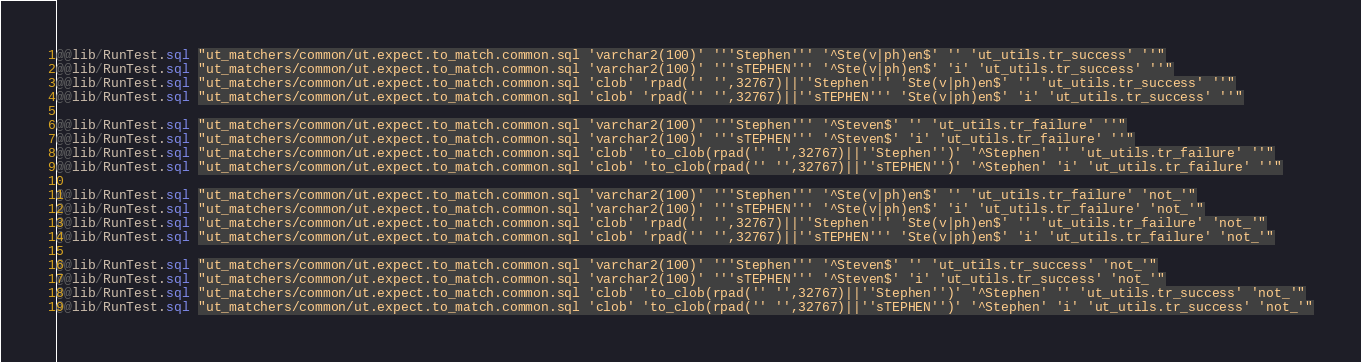Convert code to text. <code><loc_0><loc_0><loc_500><loc_500><_SQL_>@@lib/RunTest.sql "ut_matchers/common/ut.expect.to_match.common.sql 'varchar2(100)' '''Stephen''' '^Ste(v|ph)en$' '' 'ut_utils.tr_success' ''"
@@lib/RunTest.sql "ut_matchers/common/ut.expect.to_match.common.sql 'varchar2(100)' '''sTEPHEN''' '^Ste(v|ph)en$' 'i' 'ut_utils.tr_success' ''"
@@lib/RunTest.sql "ut_matchers/common/ut.expect.to_match.common.sql 'clob' 'rpad('' '',32767)||''Stephen''' 'Ste(v|ph)en$' '' 'ut_utils.tr_success' ''"
@@lib/RunTest.sql "ut_matchers/common/ut.expect.to_match.common.sql 'clob' 'rpad('' '',32767)||''sTEPHEN''' 'Ste(v|ph)en$' 'i' 'ut_utils.tr_success' ''"

@@lib/RunTest.sql "ut_matchers/common/ut.expect.to_match.common.sql 'varchar2(100)' '''Stephen''' '^Steven$' '' 'ut_utils.tr_failure' ''"
@@lib/RunTest.sql "ut_matchers/common/ut.expect.to_match.common.sql 'varchar2(100)' '''sTEPHEN''' '^Steven$' 'i' 'ut_utils.tr_failure' ''"
@@lib/RunTest.sql "ut_matchers/common/ut.expect.to_match.common.sql 'clob' 'to_clob(rpad('' '',32767)||''Stephen'')' '^Stephen' '' 'ut_utils.tr_failure' ''"
@@lib/RunTest.sql "ut_matchers/common/ut.expect.to_match.common.sql 'clob' 'to_clob(rpad('' '',32767)||''sTEPHEN'')' '^Stephen' 'i' 'ut_utils.tr_failure' ''"

@@lib/RunTest.sql "ut_matchers/common/ut.expect.to_match.common.sql 'varchar2(100)' '''Stephen''' '^Ste(v|ph)en$' '' 'ut_utils.tr_failure' 'not_'"
@@lib/RunTest.sql "ut_matchers/common/ut.expect.to_match.common.sql 'varchar2(100)' '''sTEPHEN''' '^Ste(v|ph)en$' 'i' 'ut_utils.tr_failure' 'not_'"
@@lib/RunTest.sql "ut_matchers/common/ut.expect.to_match.common.sql 'clob' 'rpad('' '',32767)||''Stephen''' 'Ste(v|ph)en$' '' 'ut_utils.tr_failure' 'not_'"
@@lib/RunTest.sql "ut_matchers/common/ut.expect.to_match.common.sql 'clob' 'rpad('' '',32767)||''sTEPHEN''' 'Ste(v|ph)en$' 'i' 'ut_utils.tr_failure' 'not_'"

@@lib/RunTest.sql "ut_matchers/common/ut.expect.to_match.common.sql 'varchar2(100)' '''Stephen''' '^Steven$' '' 'ut_utils.tr_success' 'not_'"
@@lib/RunTest.sql "ut_matchers/common/ut.expect.to_match.common.sql 'varchar2(100)' '''sTEPHEN''' '^Steven$' 'i' 'ut_utils.tr_success' 'not_'"
@@lib/RunTest.sql "ut_matchers/common/ut.expect.to_match.common.sql 'clob' 'to_clob(rpad('' '',32767)||''Stephen'')' '^Stephen' '' 'ut_utils.tr_success' 'not_'"
@@lib/RunTest.sql "ut_matchers/common/ut.expect.to_match.common.sql 'clob' 'to_clob(rpad('' '',32767)||''sTEPHEN'')' '^Stephen' 'i' 'ut_utils.tr_success' 'not_'"
</code> 